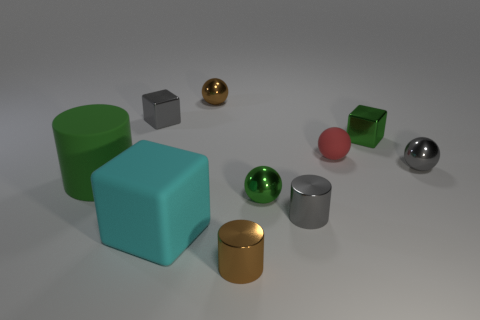How many other things are made of the same material as the tiny red ball?
Your answer should be compact. 2. Is the number of tiny spheres that are to the left of the big cyan matte object less than the number of gray things that are left of the tiny rubber ball?
Ensure brevity in your answer.  Yes. Do the red object that is behind the gray metal sphere and the small gray ball have the same size?
Keep it short and to the point. Yes. Are there fewer green things on the left side of the large cyan rubber object than gray things?
Your answer should be compact. Yes. There is a block in front of the object to the left of the small gray block; what is its size?
Make the answer very short. Large. Are there any other things that are the same shape as the big green thing?
Your response must be concise. Yes. Are there fewer small cylinders than tiny green cubes?
Keep it short and to the point. No. The cube that is both behind the large green cylinder and on the left side of the small brown shiny cylinder is made of what material?
Offer a very short reply. Metal. There is a tiny shiny cube that is in front of the tiny gray shiny block; are there any tiny gray things behind it?
Give a very brief answer. Yes. How many things are gray metal cylinders or tiny gray things?
Keep it short and to the point. 3. 